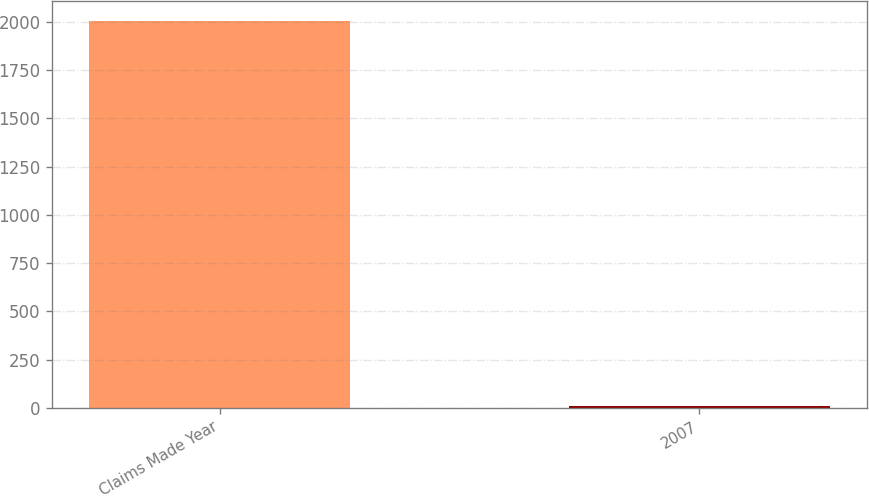Convert chart. <chart><loc_0><loc_0><loc_500><loc_500><bar_chart><fcel>Claims Made Year<fcel>2007<nl><fcel>2007<fcel>11<nl></chart> 